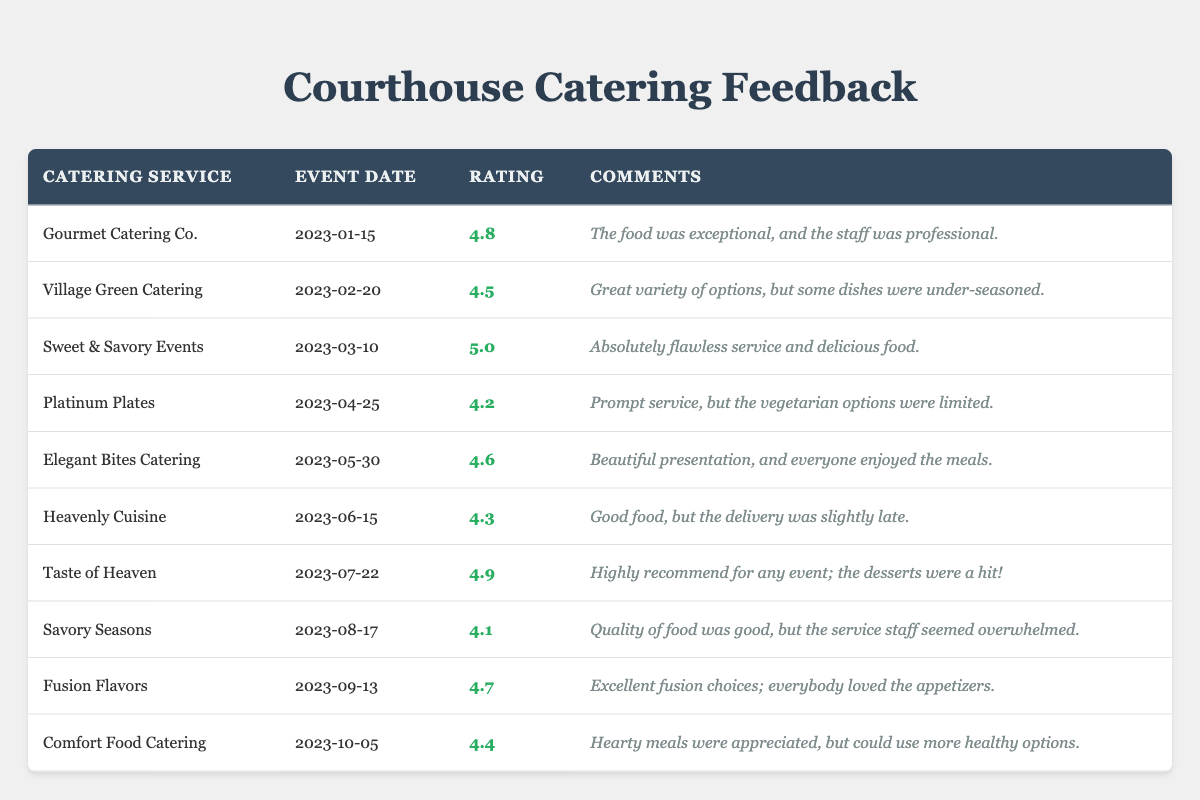What is the highest feedback rating among the catering services? By reviewing the feedback ratings provided in the table, the service with the highest rating is "Sweet & Savory Events," which has a rating of 5.0.
Answer: 5.0 Which catering service received a rating of 4.1? The table shows that "Savory Seasons" has a feedback rating of 4.1.
Answer: Savory Seasons What is the average feedback rating for all catering services? To find the average, sum up all the ratings: (4.8 + 4.5 + 5.0 + 4.2 + 4.6 + 4.3 + 4.9 + 4.1 + 4.7 + 4.4) = 46.5, then divide by 10 (the number of services), resulting in an average rating of 4.65.
Answer: 4.65 Did "Heavenly Cuisine" receive a rating above 4.5? "Heavenly Cuisine" has a feedback rating of 4.3, which is not above 4.5.
Answer: No What feedback rating is the difference between "Taste of Heaven" and "Elegant Bites Catering"? "Taste of Heaven" has a rating of 4.9 and "Elegant Bites Catering" has a rating of 4.6. The difference is 4.9 - 4.6 = 0.3.
Answer: 0.3 Which catering services have a rating of 4.5 or higher? The services with a rating of 4.5 or higher are "Gourmet Catering Co.", "Village Green Catering", "Sweet & Savory Events", "Elegant Bites Catering", "Taste of Heaven", "Fusion Flavors", and "Comfort Food Catering".
Answer: 7 services What is the total number of events rated? By counting the number of entries in the table, there are 10 catering services listed, indicating 10 events rated.
Answer: 10 Which service had the lowest feedback rating and what was it? The service with the lowest rating is "Savory Seasons", with a feedback rating of 4.1.
Answer: Savory Seasons, 4.1 Is there any catering service with a feedback rating of 4.2? Yes, the catering service "Platinum Plates" has a feedback rating of 4.2.
Answer: Yes Which catering service received the most positive comment? "Sweet & Savory Events" received the most positive comment, stating it had "absolutely flawless service and delicious food."
Answer: Sweet & Savory Events 